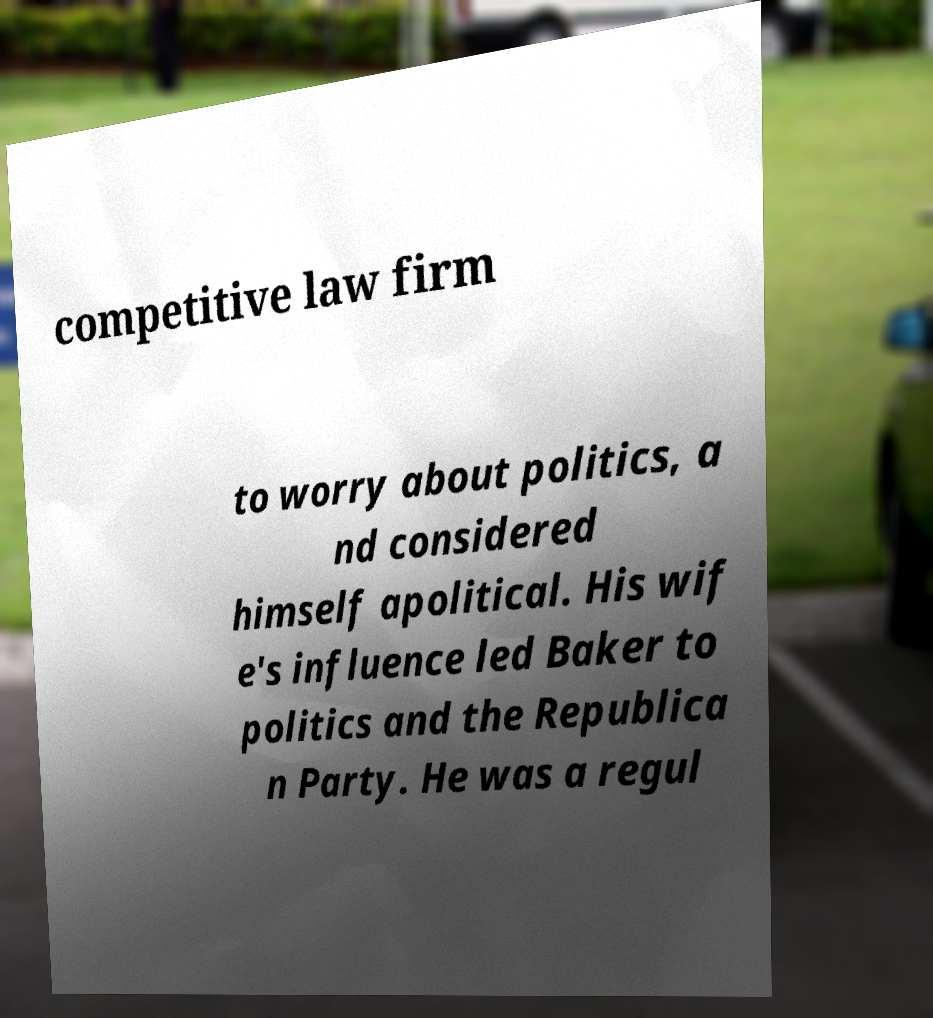Could you extract and type out the text from this image? competitive law firm to worry about politics, a nd considered himself apolitical. His wif e's influence led Baker to politics and the Republica n Party. He was a regul 